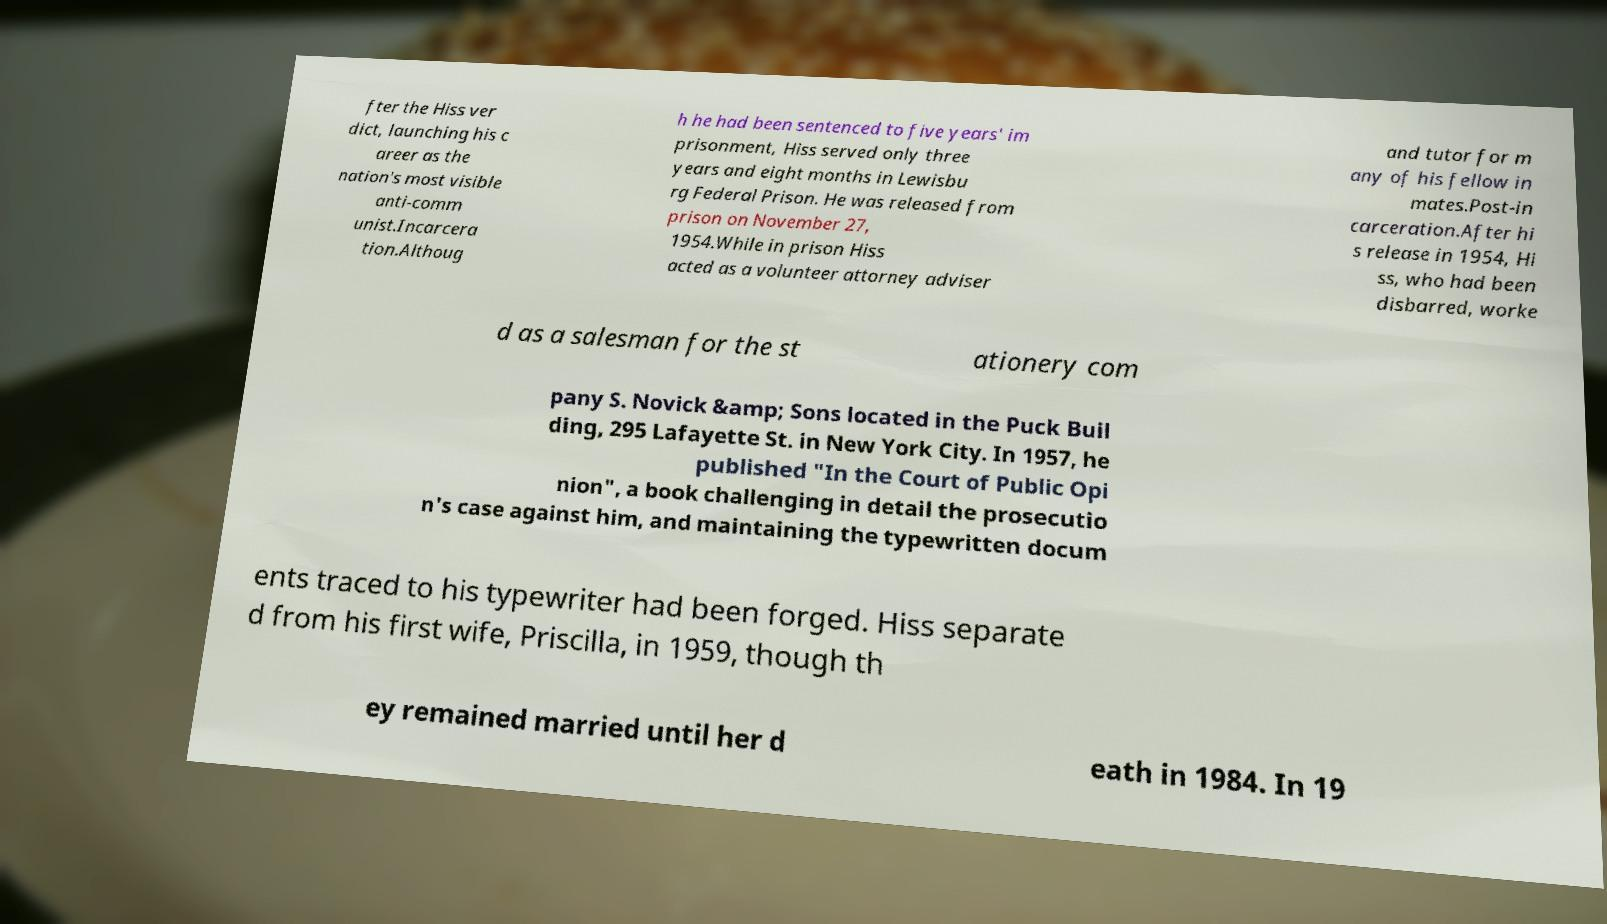Could you extract and type out the text from this image? fter the Hiss ver dict, launching his c areer as the nation's most visible anti-comm unist.Incarcera tion.Althoug h he had been sentenced to five years' im prisonment, Hiss served only three years and eight months in Lewisbu rg Federal Prison. He was released from prison on November 27, 1954.While in prison Hiss acted as a volunteer attorney adviser and tutor for m any of his fellow in mates.Post-in carceration.After hi s release in 1954, Hi ss, who had been disbarred, worke d as a salesman for the st ationery com pany S. Novick &amp; Sons located in the Puck Buil ding, 295 Lafayette St. in New York City. In 1957, he published "In the Court of Public Opi nion", a book challenging in detail the prosecutio n's case against him, and maintaining the typewritten docum ents traced to his typewriter had been forged. Hiss separate d from his first wife, Priscilla, in 1959, though th ey remained married until her d eath in 1984. In 19 